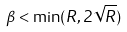<formula> <loc_0><loc_0><loc_500><loc_500>\beta < \min ( R , 2 \sqrt { R } )</formula> 